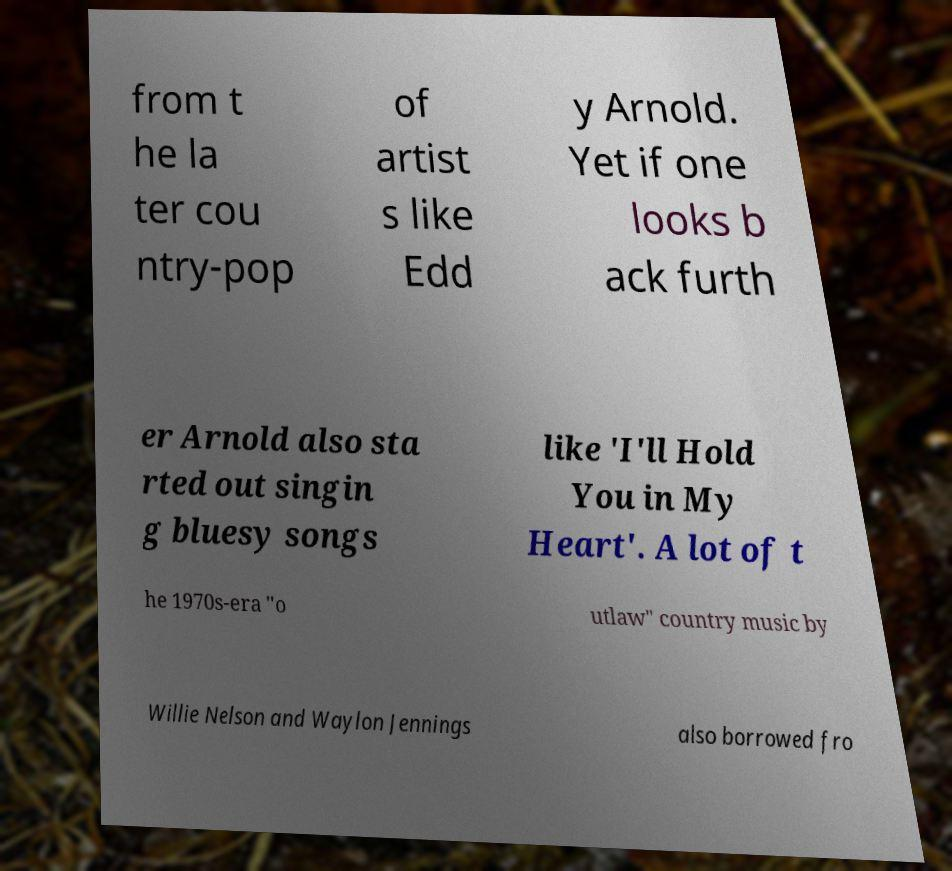Could you assist in decoding the text presented in this image and type it out clearly? from t he la ter cou ntry-pop of artist s like Edd y Arnold. Yet if one looks b ack furth er Arnold also sta rted out singin g bluesy songs like 'I'll Hold You in My Heart'. A lot of t he 1970s-era "o utlaw" country music by Willie Nelson and Waylon Jennings also borrowed fro 